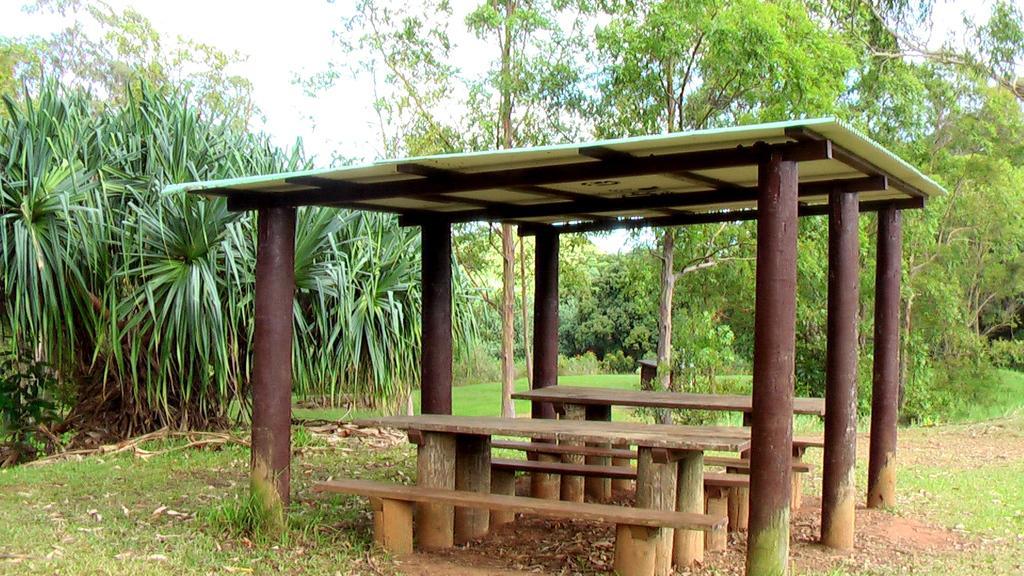Could you give a brief overview of what you see in this image? In this image we can see pergola with wooden benches. Here we can see the grass, dry leaves, trees and the sky in the background. 